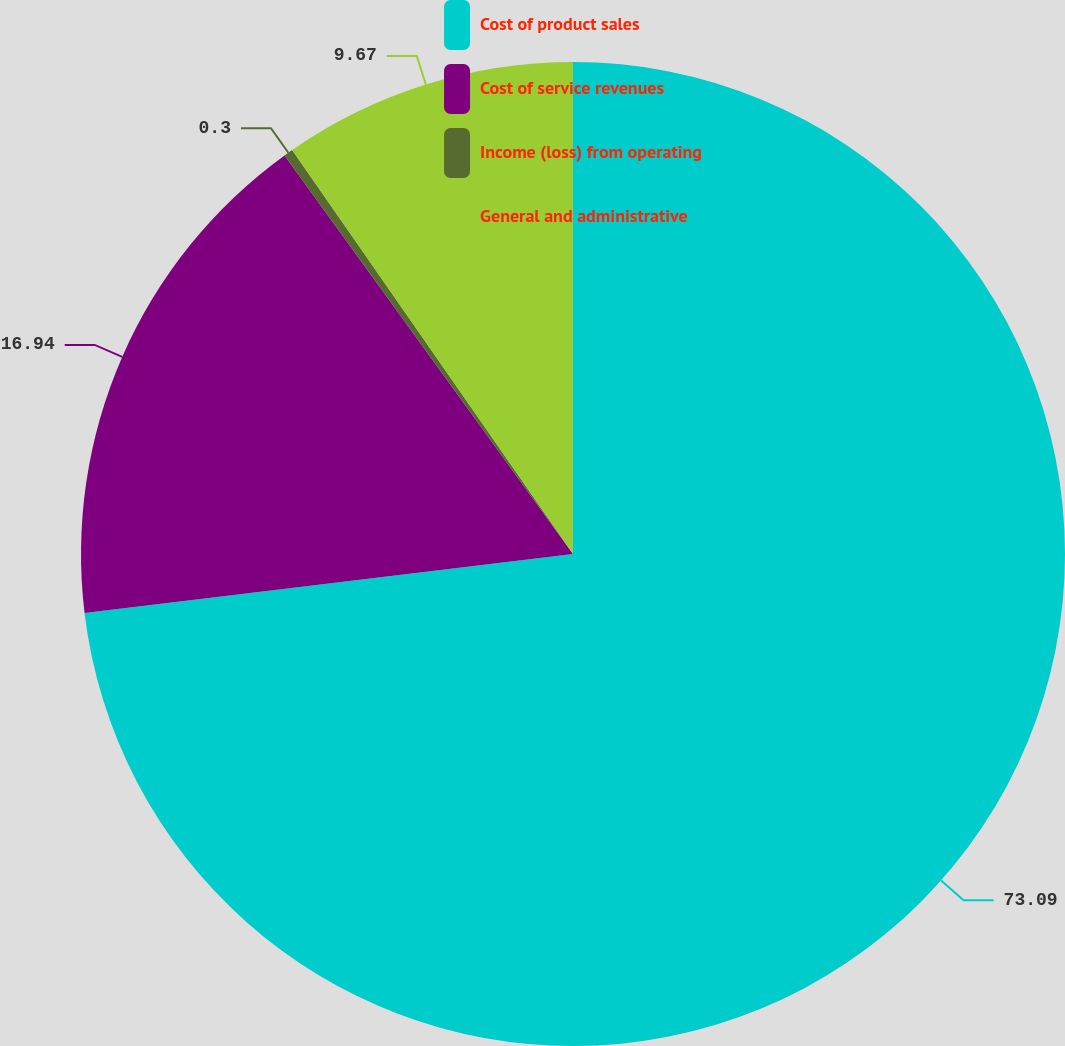Convert chart. <chart><loc_0><loc_0><loc_500><loc_500><pie_chart><fcel>Cost of product sales<fcel>Cost of service revenues<fcel>Income (loss) from operating<fcel>General and administrative<nl><fcel>73.09%<fcel>16.94%<fcel>0.3%<fcel>9.67%<nl></chart> 